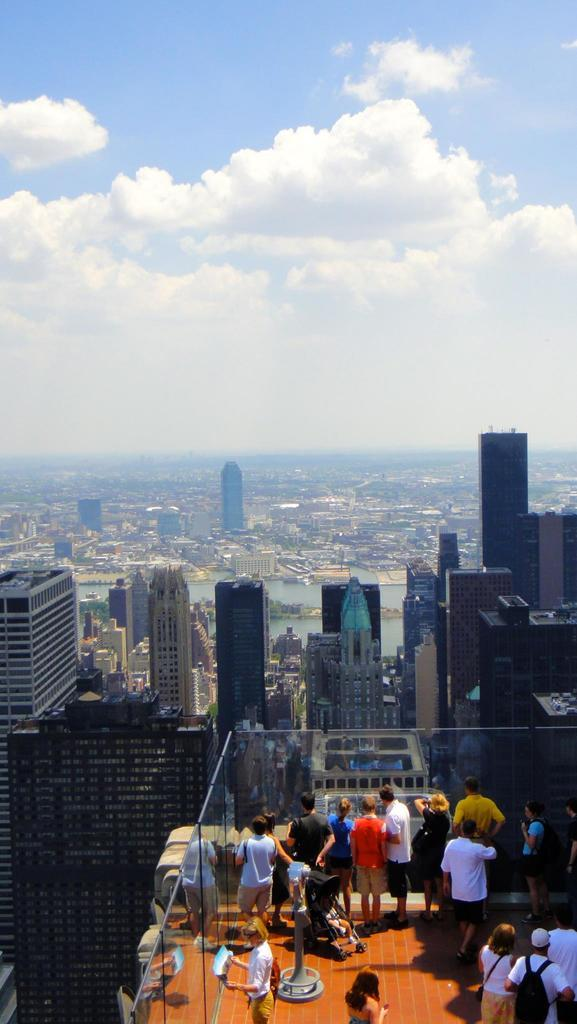What type of structures are visible in the image? There are buildings in the image. Can you describe the activity happening on one of the buildings? There are many people on one of the buildings. What can be seen in the sky at the top of the image? There are clouds in the sky at the top of the image. Can you tell me how many girls are controlling the ducks in the image? There are no girls or ducks present in the image. 